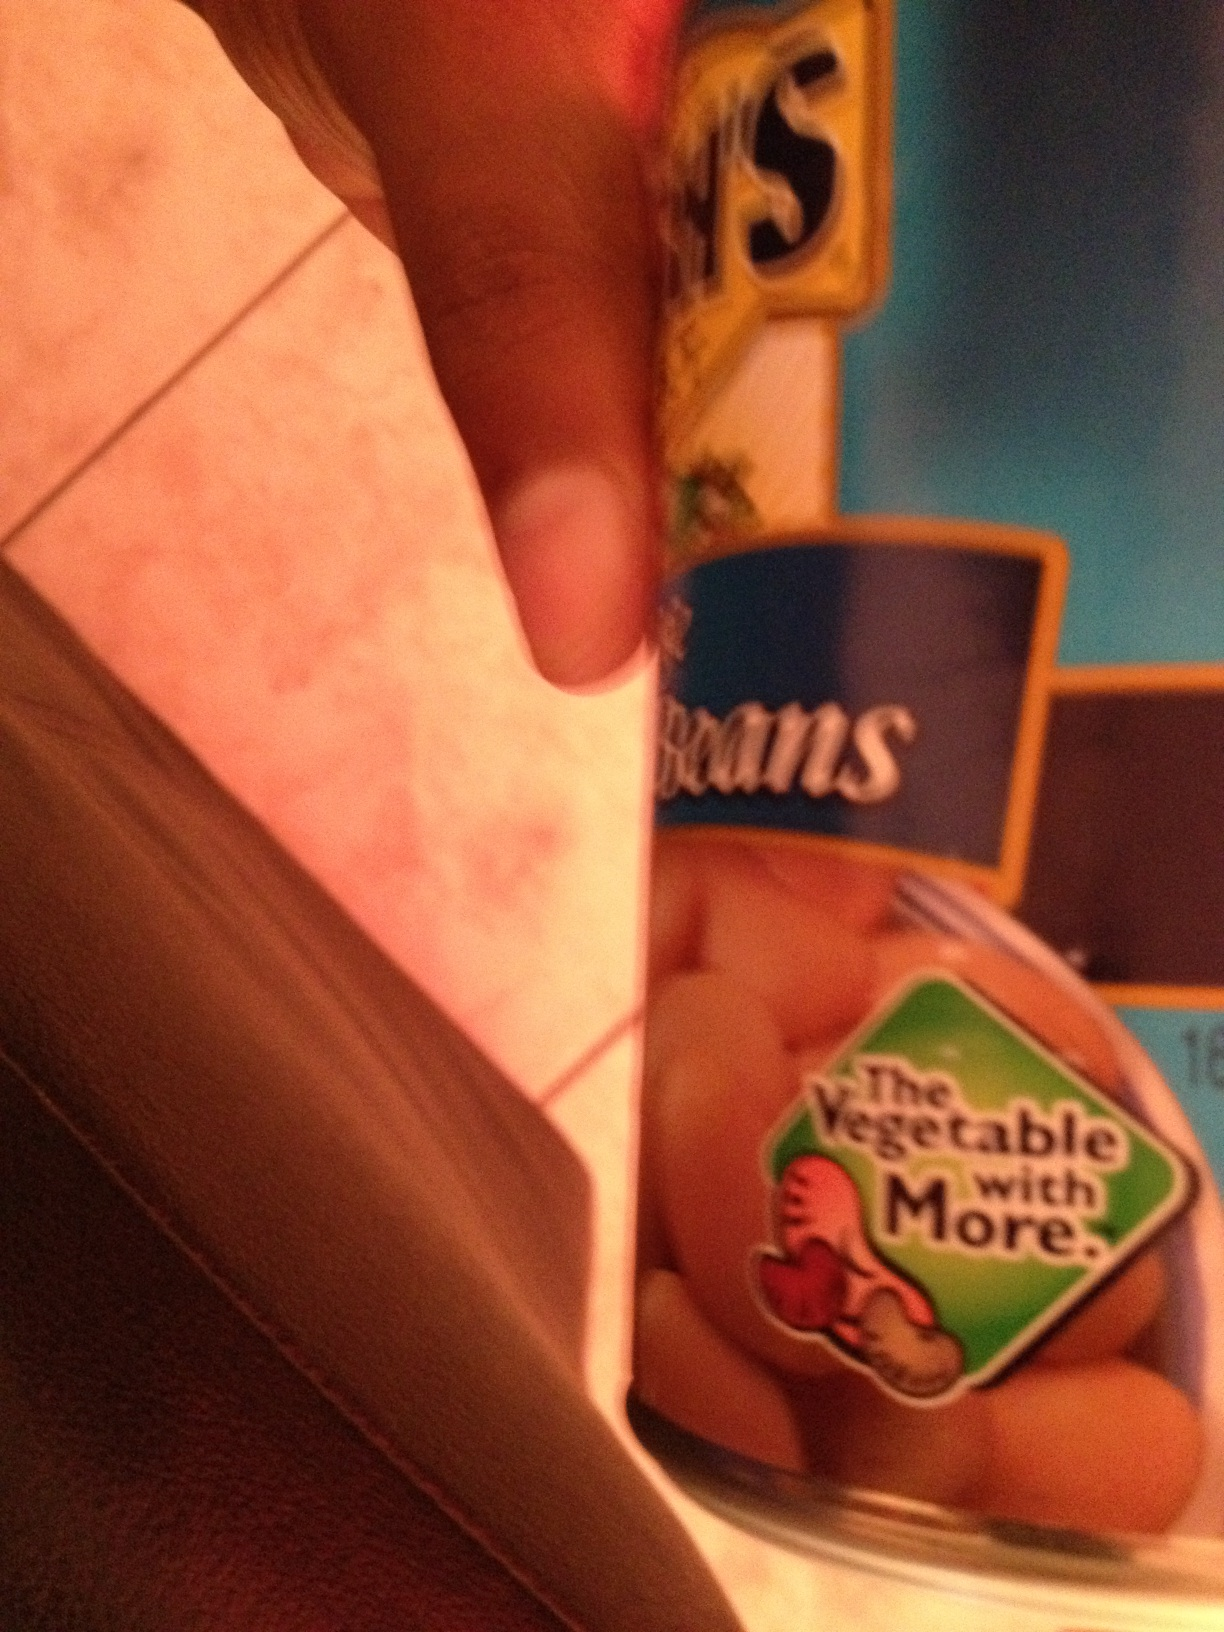hello can you please tell me what a caN of beans is thank you from Vizwiz bush brand pinto beans 